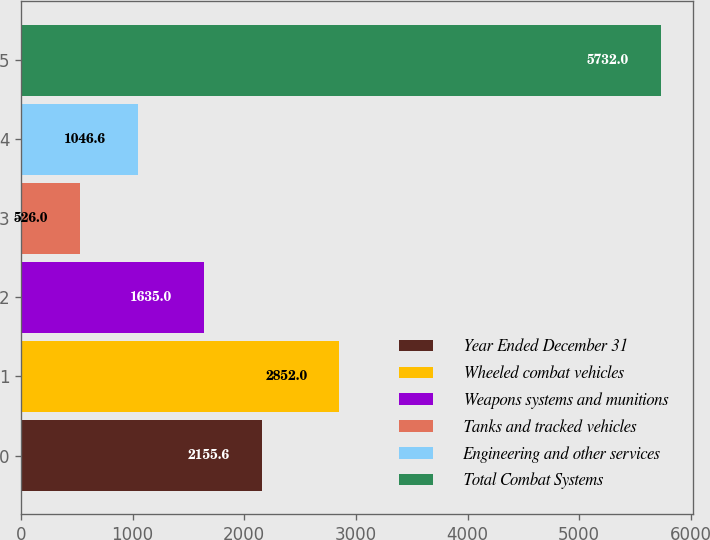Convert chart. <chart><loc_0><loc_0><loc_500><loc_500><bar_chart><fcel>Year Ended December 31<fcel>Wheeled combat vehicles<fcel>Weapons systems and munitions<fcel>Tanks and tracked vehicles<fcel>Engineering and other services<fcel>Total Combat Systems<nl><fcel>2155.6<fcel>2852<fcel>1635<fcel>526<fcel>1046.6<fcel>5732<nl></chart> 